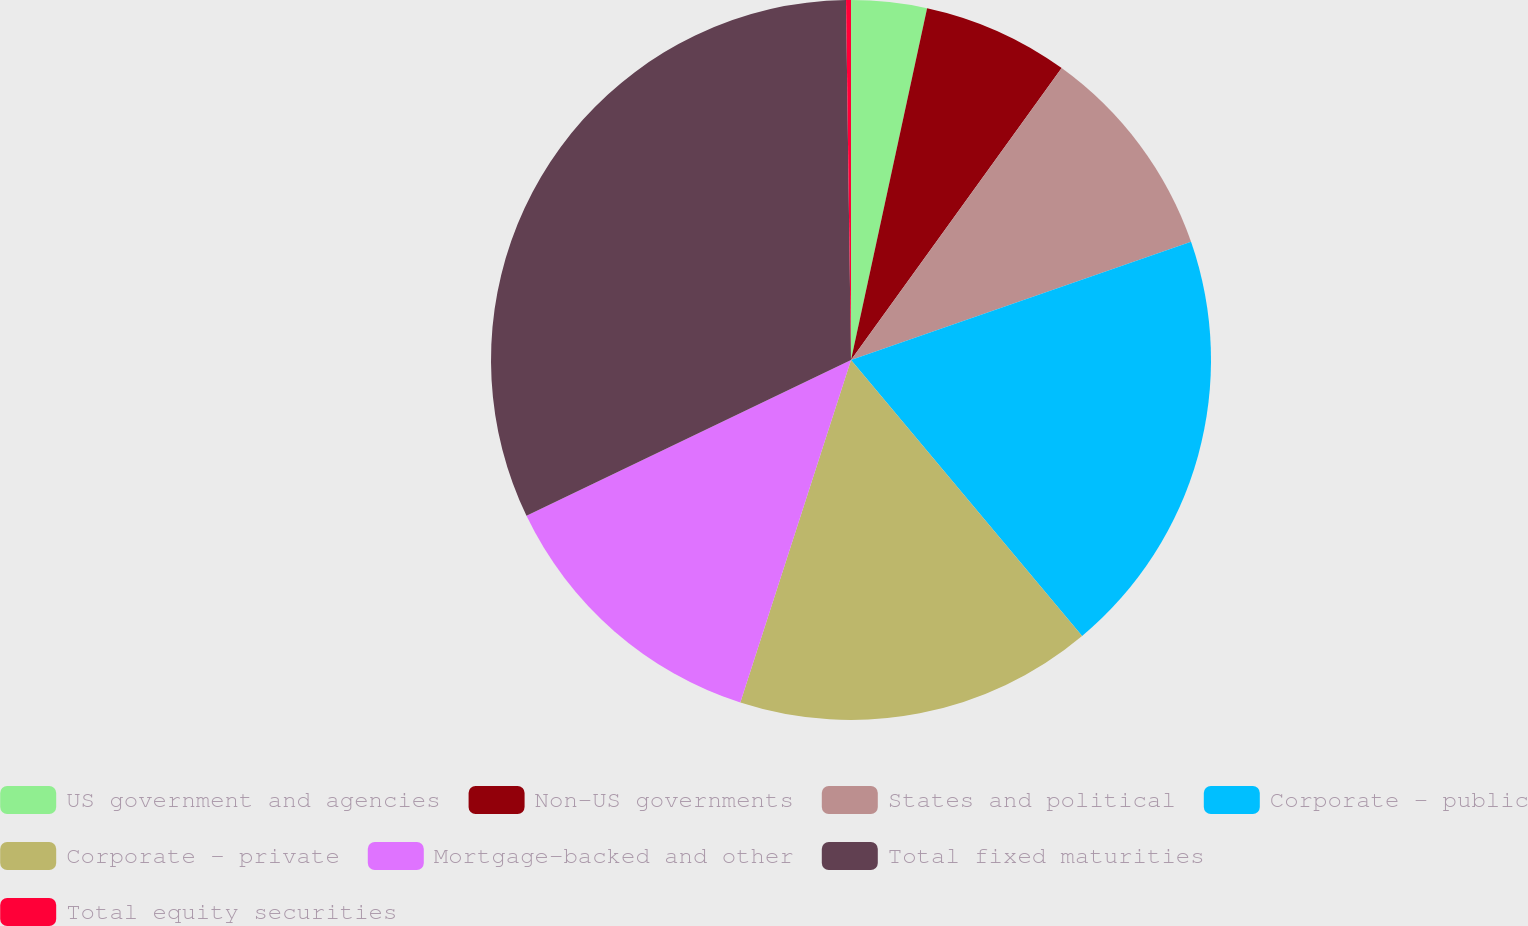Convert chart to OTSL. <chart><loc_0><loc_0><loc_500><loc_500><pie_chart><fcel>US government and agencies<fcel>Non-US governments<fcel>States and political<fcel>Corporate - public<fcel>Corporate - private<fcel>Mortgage-backed and other<fcel>Total fixed maturities<fcel>Total equity securities<nl><fcel>3.39%<fcel>6.56%<fcel>9.73%<fcel>19.23%<fcel>16.07%<fcel>12.9%<fcel>31.91%<fcel>0.22%<nl></chart> 